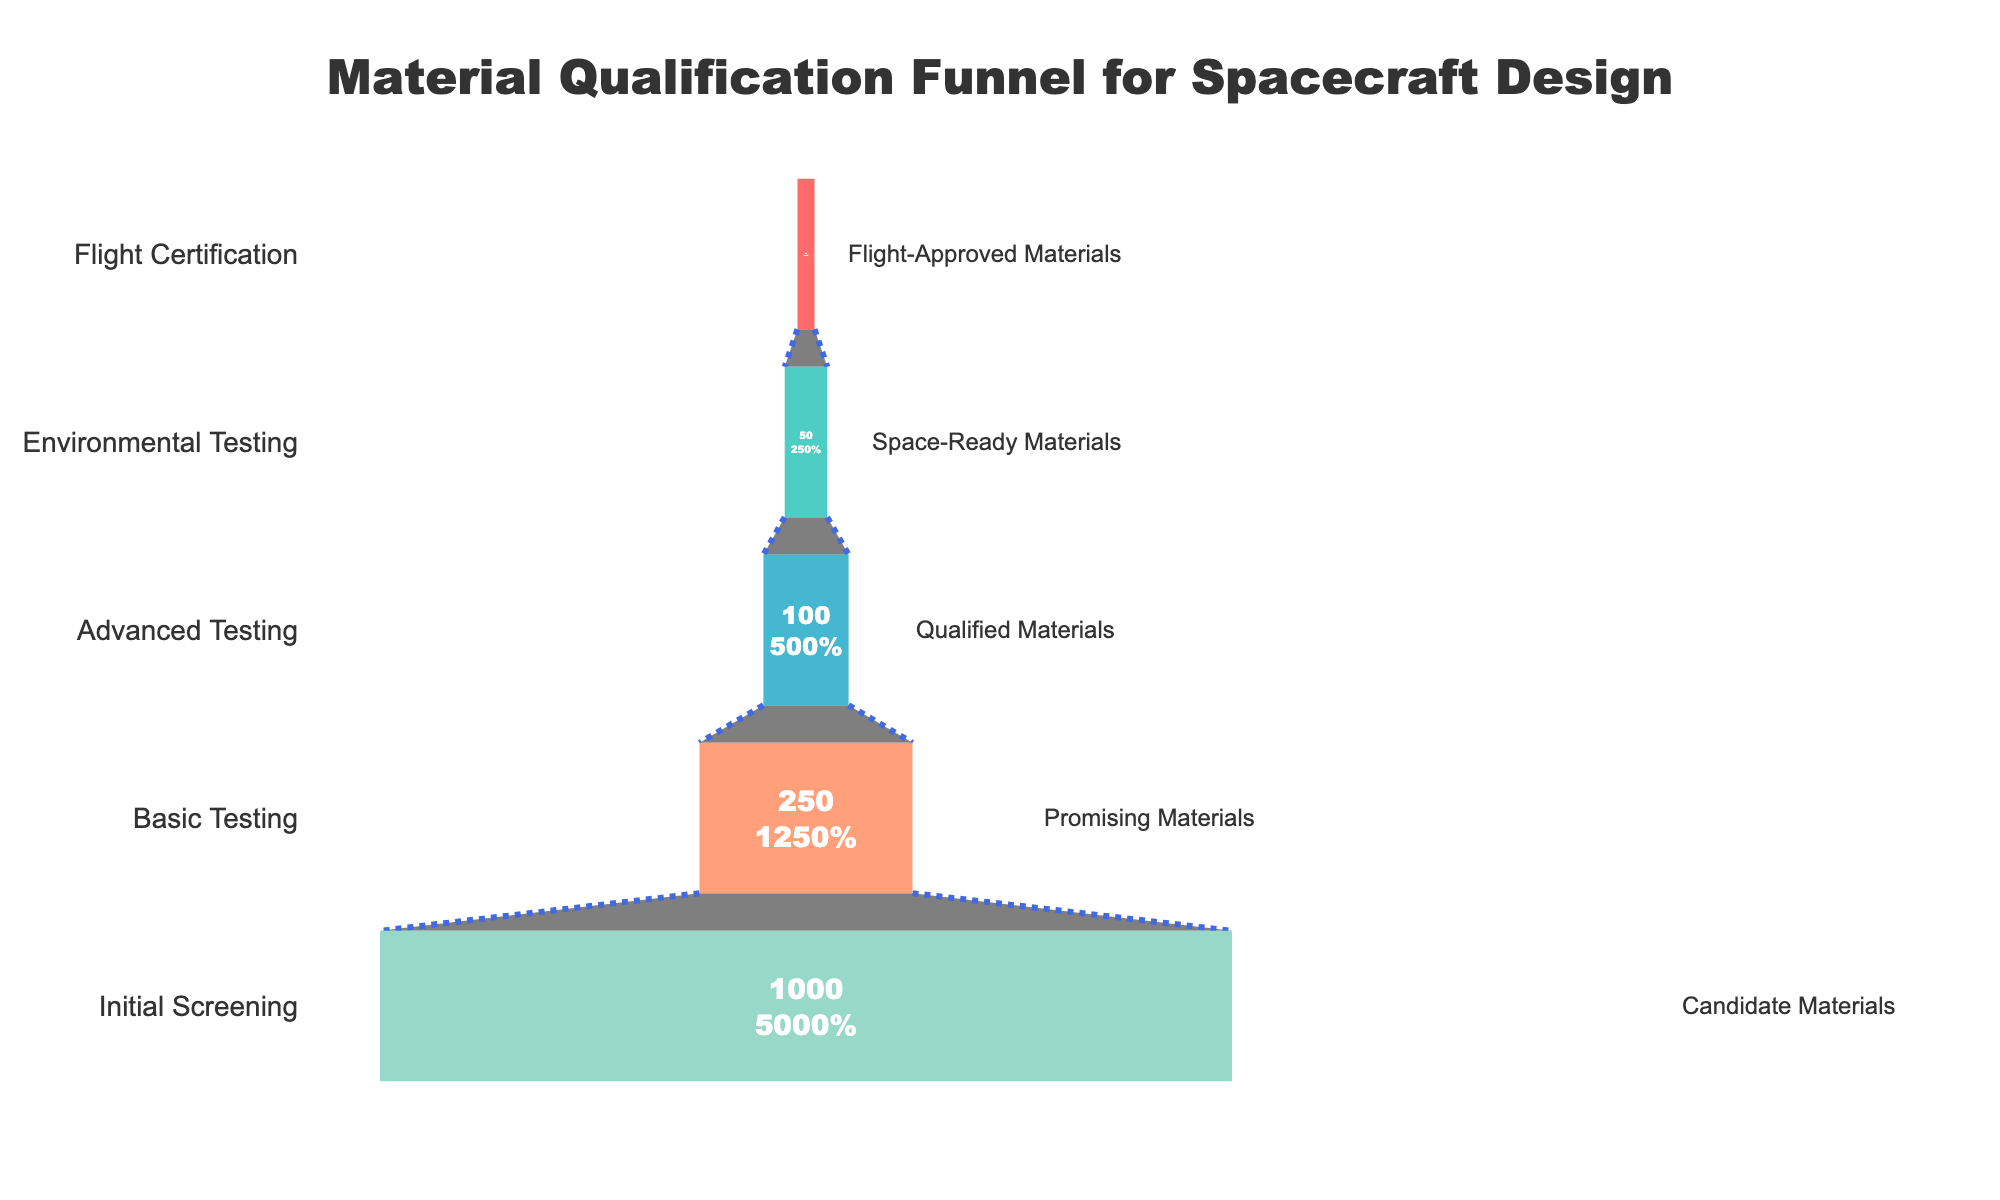What is the title of the funnel chart? The title is located at the top of the chart and summarizes what the chart represents. By reading it, you can understand that the funnel chart is about the material qualification process in spacecraft design.
Answer: Material Qualification Funnel for Spacecraft Design What percentage of candidate materials pass the Initial Screening stage? The text inside the funnel blocks shows the percentage relative to the initial value of 1000. For the Initial Screening stage, the block is labeled with "1000 100%," indicating that 100% of candidate materials start at this stage.
Answer: 100% How many materials pass the Advanced Testing stage? Advanced Testing data is visible in the middle of the funnel and indicates the number of materials after this stage. The funnel block labeled with "100" represents the number of materials that pass the Advanced Testing stage.
Answer: 100 What is the decrease in the number of materials from Basic Testing to Advanced Testing? Basic Testing has 250 materials, whereas Advanced Testing has 100. To find the decrease, subtract the Advanced Testing number from the Basic Testing number: 250 - 100 = 150.
Answer: 150 What percentage of materials pass from Basic Testing to Advanced Testing? The percentage can be calculated by dividing the number of materials in Advanced Testing (100) by the number of materials in Basic Testing (250) and multiplying by 100: (100 / 250) * 100 = 40%.
Answer: 40% Which stage shows the greatest drop in the number of materials? By comparing the differences between consecutive stages, the greatest drop is identified between Basic Testing (250 materials) and Advanced Testing (100 materials), which is a decrease of 150 materials. This is the largest drop observed.
Answer: Basic Testing to Advanced Testing How many more materials pass the Environmental Testing stage compared to the Flight Certification stage? Environmental Testing has 50 materials, and Flight Certification has 20. Subtract the two numbers to find the difference: 50 - 20 = 30.
Answer: 30 What is the final percentage of materials that achieve Flight Certification? The final stage, Flight Certification, has 20 materials. To find the final percentage from the initial 1000 materials: (20 / 1000) * 100 = 2%.
Answer: 2% How many stages are there in this material qualification process? By counting the number of distinct labeled stages within the funnel chart, it is clear there are five stages: Initial Screening, Basic Testing, Advanced Testing, Environmental Testing, and Flight Certification.
Answer: 5 What color represents the Flight-Approved Materials stage? The color of the block representing the Flight-Approved Materials stage is the lightest shade in the chart, which is generally represented in the light turquoise color as inferred from the color gradient used in the chart.
Answer: Light turquoise 